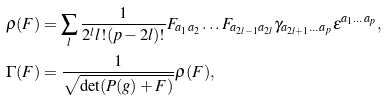<formula> <loc_0><loc_0><loc_500><loc_500>\rho ( F ) & = \sum _ { l } \frac { 1 } { 2 ^ { l } l ! ( p - 2 l ) ! } F _ { a _ { 1 } a _ { 2 } } \dots F _ { a _ { 2 l - 1 } a _ { 2 l } } \gamma _ { a _ { 2 l + 1 } \dots a _ { p } } \epsilon ^ { a _ { 1 } \dots a _ { p } } , \\ \Gamma ( F ) & = \frac { 1 } { \sqrt { \det ( P ( g ) + F ) } } \rho ( F ) ,</formula> 